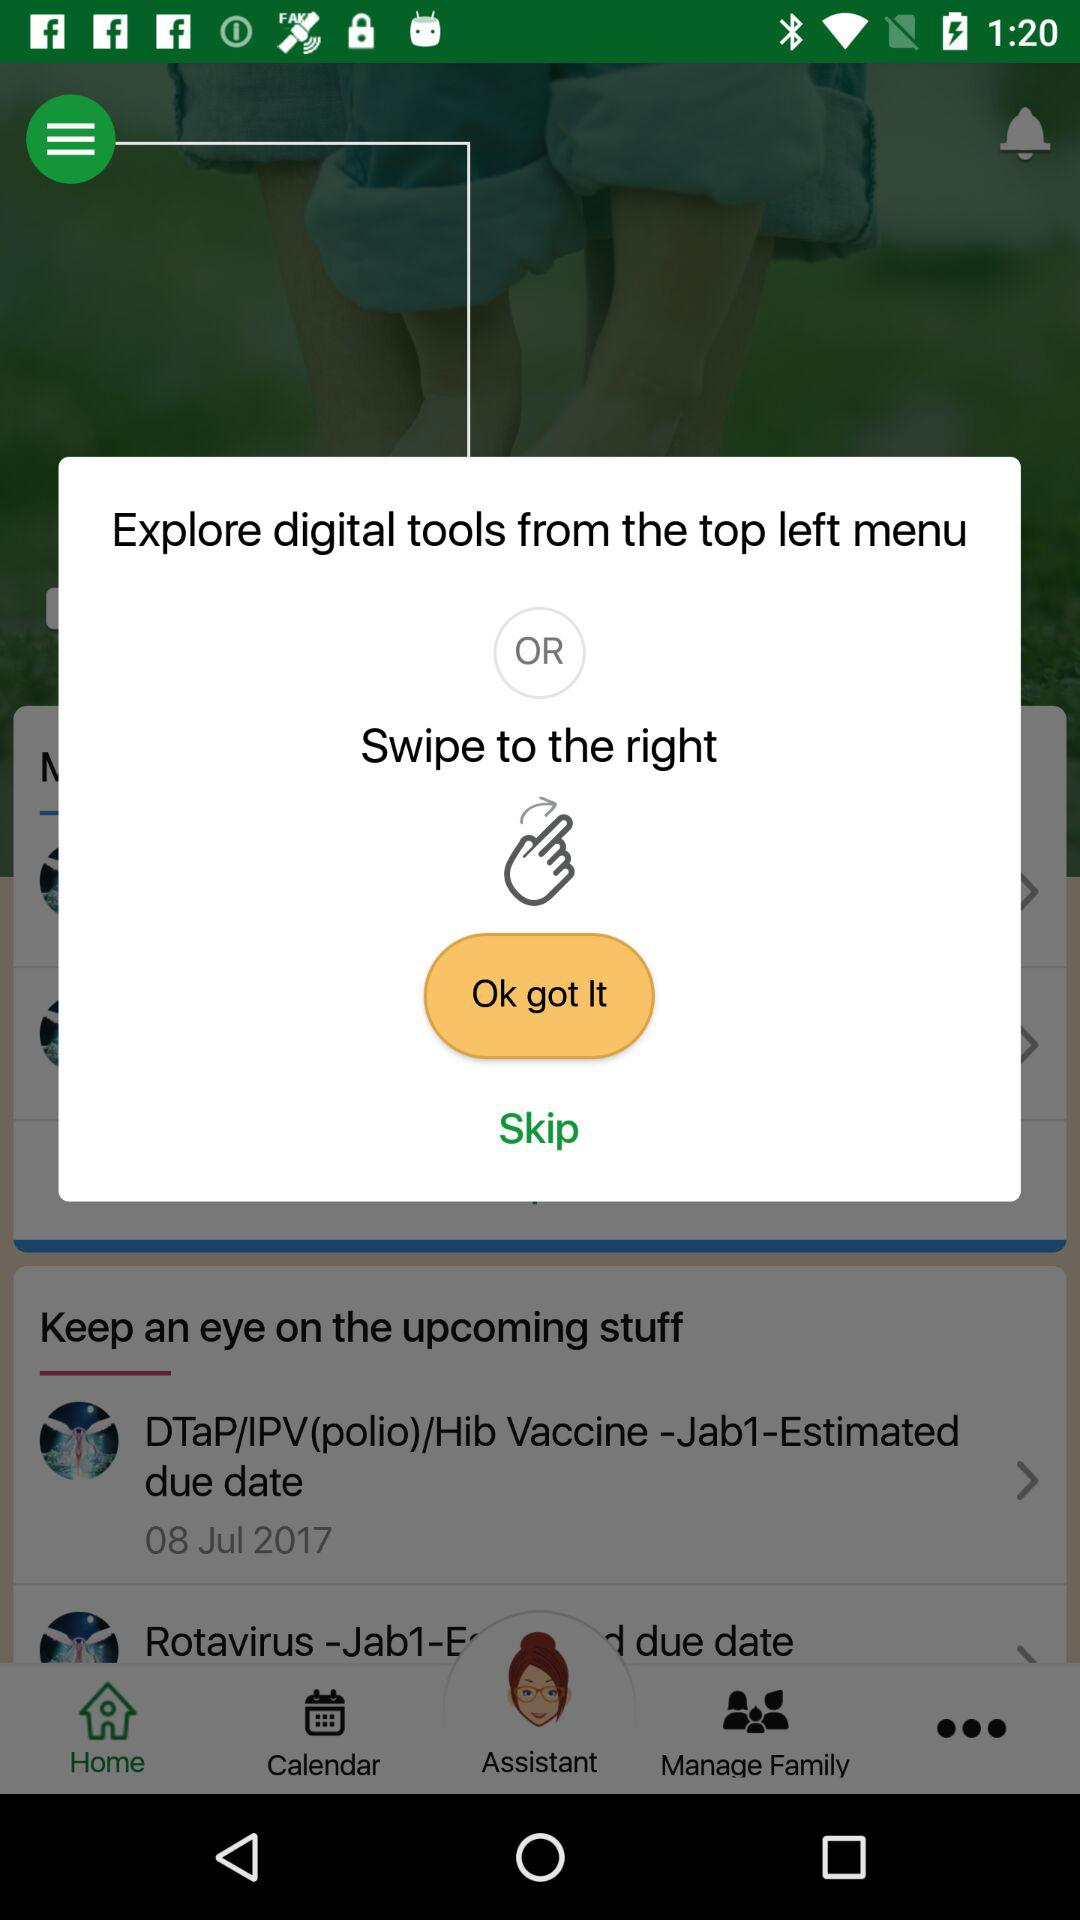From where can we explore the digital tools? You can explore the digital tools either from the top-left menu or by swiping to the right. 